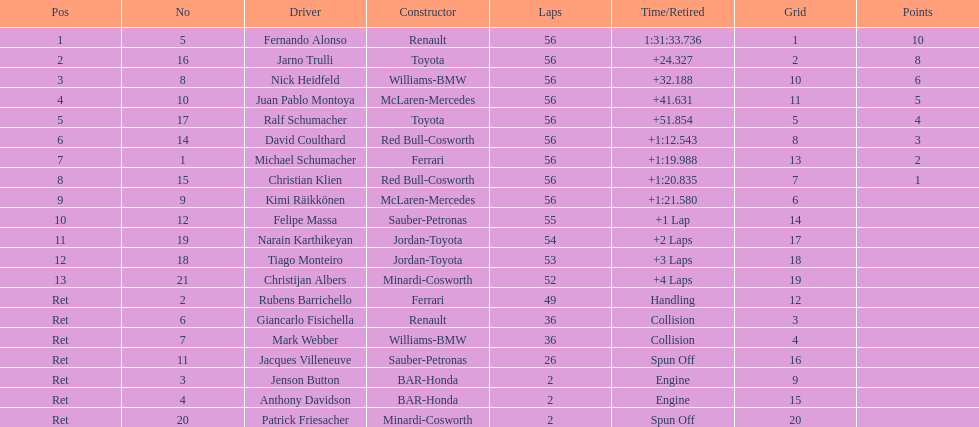Who was the last driver to actually finish the race? Christijan Albers. 